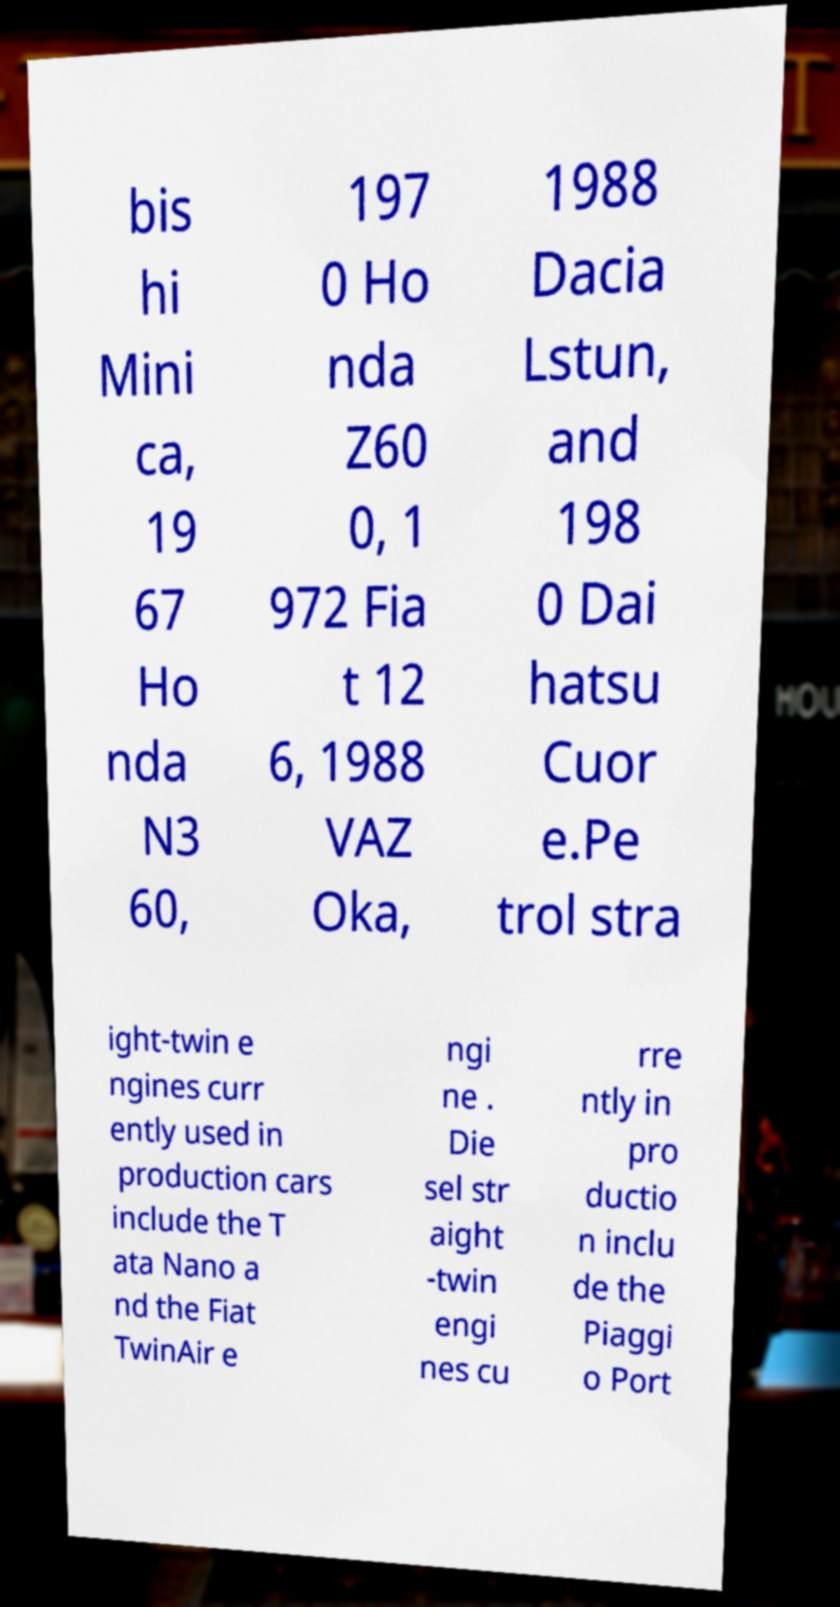Can you accurately transcribe the text from the provided image for me? bis hi Mini ca, 19 67 Ho nda N3 60, 197 0 Ho nda Z60 0, 1 972 Fia t 12 6, 1988 VAZ Oka, 1988 Dacia Lstun, and 198 0 Dai hatsu Cuor e.Pe trol stra ight-twin e ngines curr ently used in production cars include the T ata Nano a nd the Fiat TwinAir e ngi ne . Die sel str aight -twin engi nes cu rre ntly in pro ductio n inclu de the Piaggi o Port 